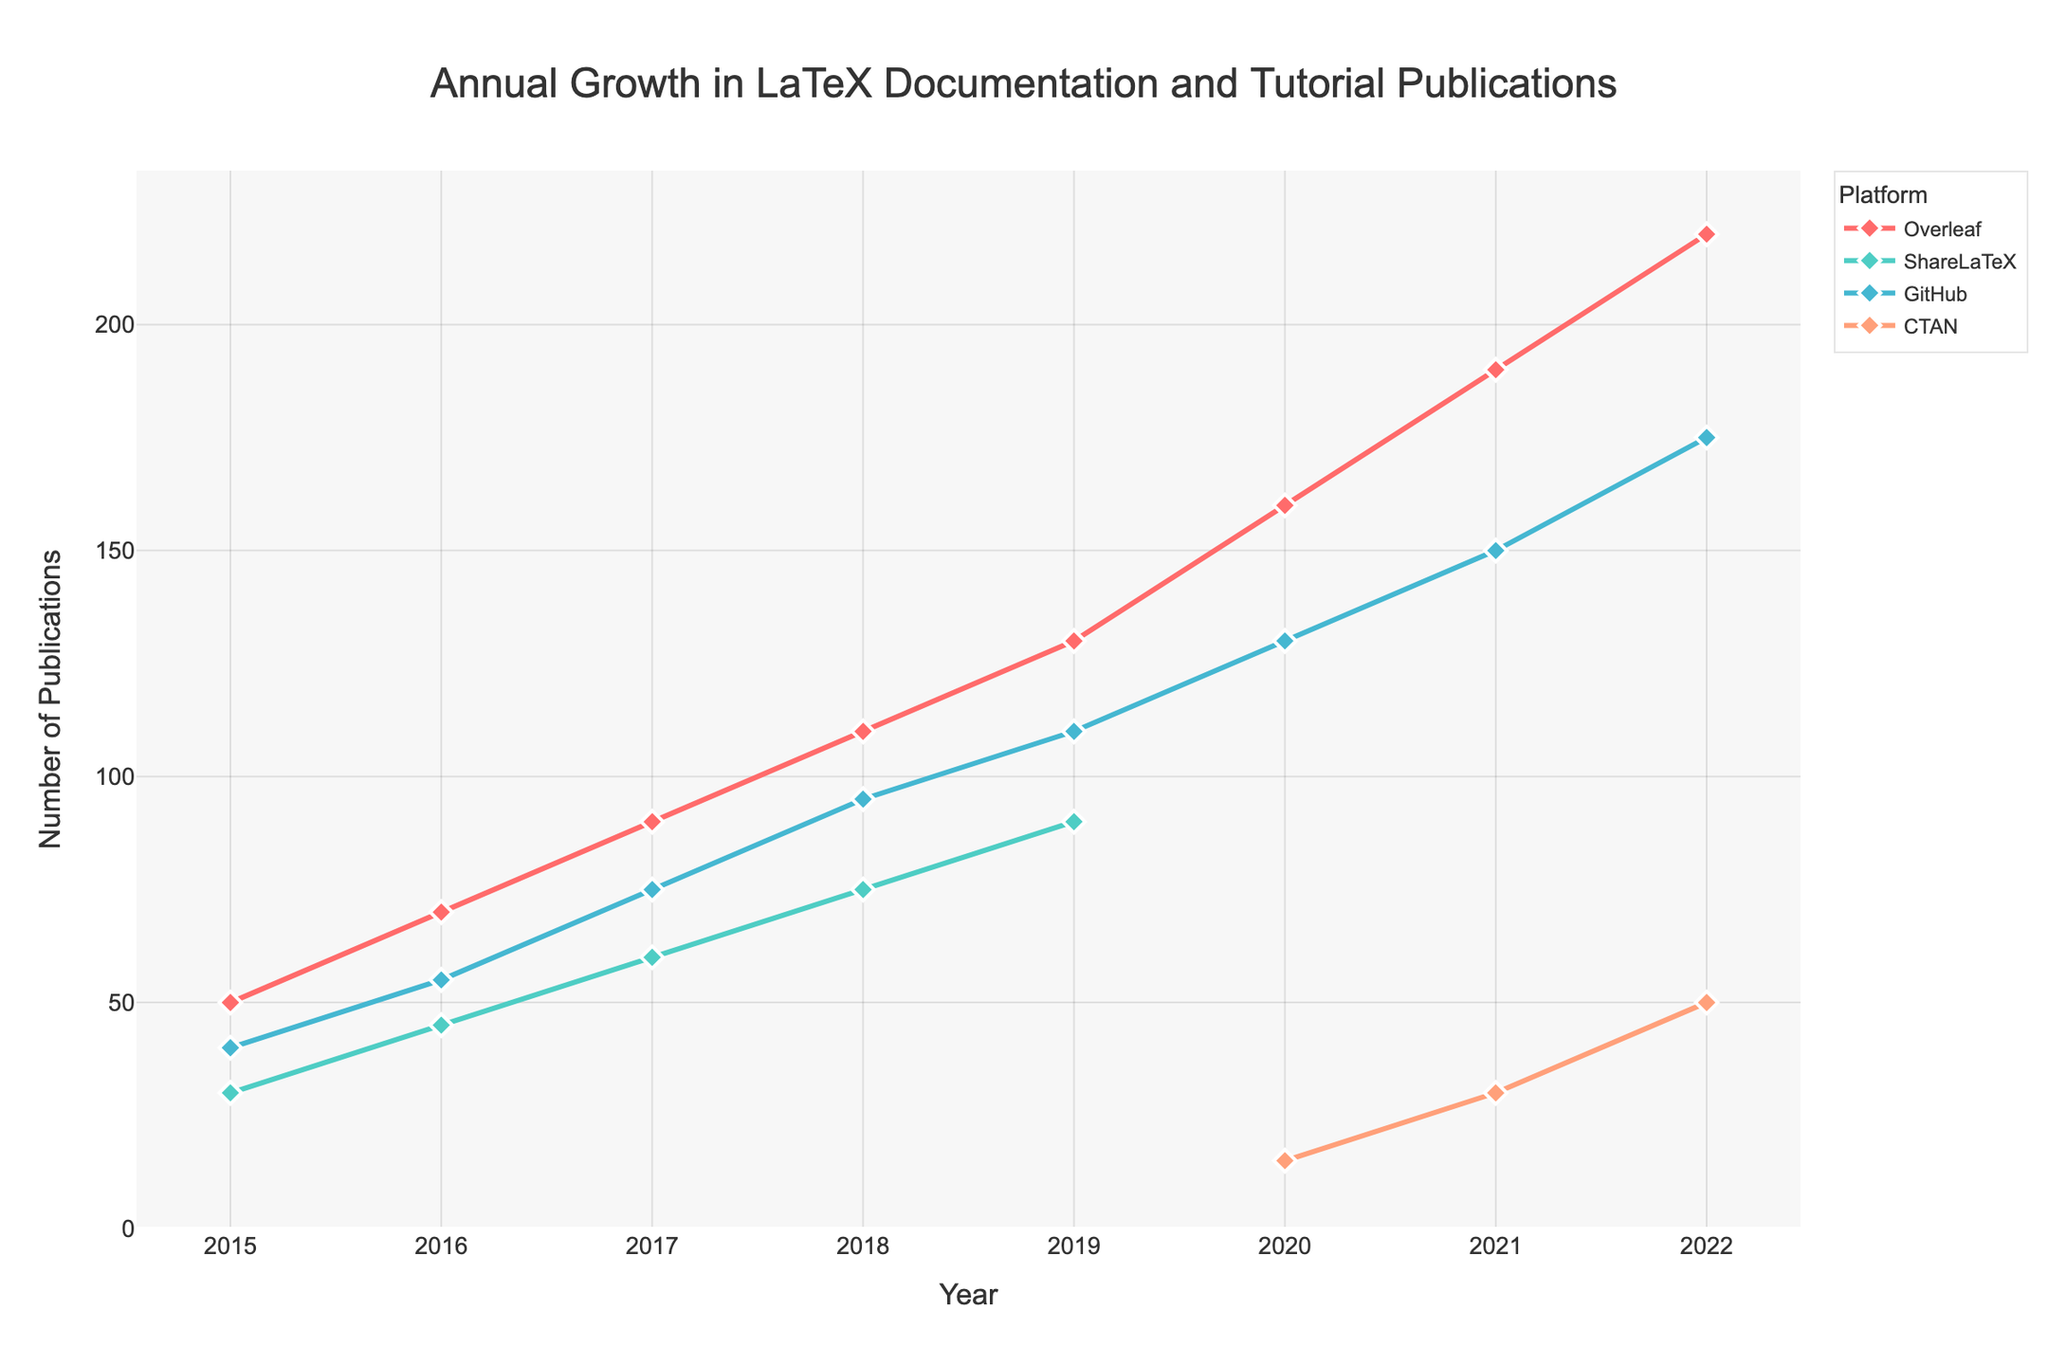What's the title of the figure? The title is usually located at the top of the figure and is typically the largest text. The title in this figure is "Annual Growth in LaTeX Documentation and Tutorial Publications".
Answer: Annual Growth in LaTeX Documentation and Tutorial Publications How many platforms are tracked in the figure? The legend indicates the number of unique platforms. We see four colored lines and symbols in the legend, representing Overleaf, ShareLaTeX, GitHub, and CTAN.
Answer: 4 Which year saw the highest number of publications for Overleaf? By looking at the Overleaf line (red) on the graph, we see the peak point in 2022.
Answer: 2022 What is the total number of publications recorded by GitHub in 2019 and 2020? From the graph, in 2019 GitHub has 110 publications and in 2020, it has 130 publications. Summing these up, 110 + 130 = 240.
Answer: 240 What is the trend of ShareLaTeX publications from 2015 to 2019? Observing the green line for ShareLaTeX, we notice an upward trend from 30 in 2015 to 90 in 2019, indicating a steady increase.
Answer: Steady increase Which platform had the fewest publications in 2020? From the graph, the CTAN line starts in 2020 with a point at 15 publications, which is less than any other platform that year.
Answer: CTAN How much did Overleaf publications increase from 2015 to 2022? In 2015, Overleaf had 50 publications, and in 2022, it had 220. The increase is 220 - 50 = 170.
Answer: 170 Did any platform show a decline in publications at any time period in the figure? By examining the lines, none of the platforms show a decline at any point between the years shown. Each line only increases or remains flat.
Answer: No Which platform first appeared in the figure in 2020? From the graph, CTAN's line starts at 2020, indicating its first appearance that year.
Answer: CTAN 